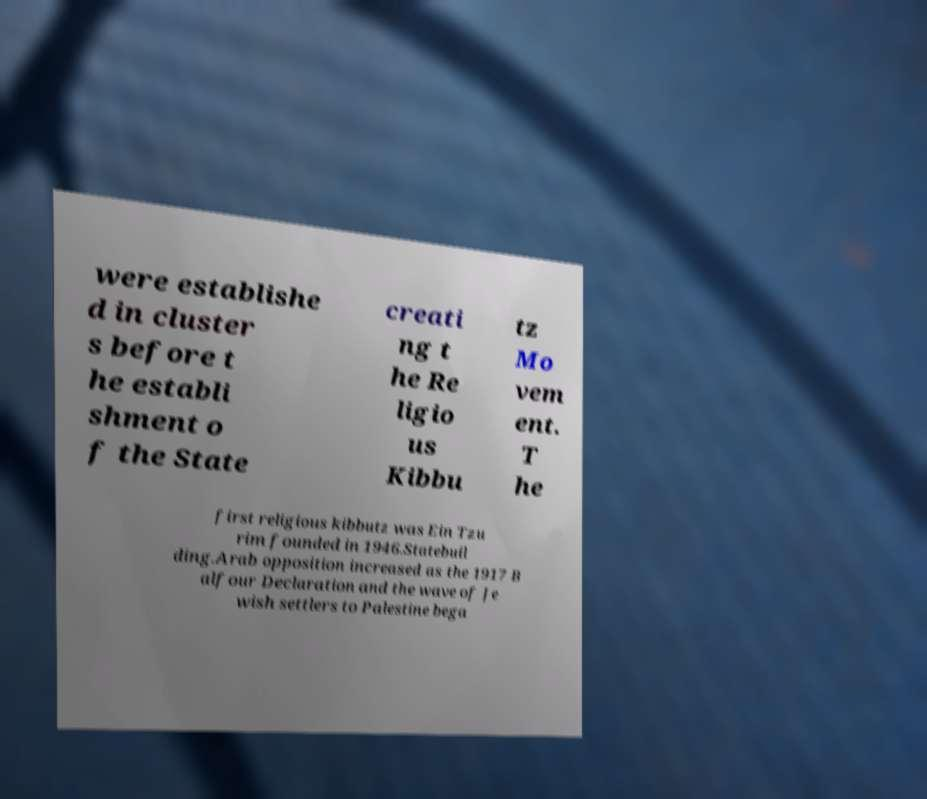For documentation purposes, I need the text within this image transcribed. Could you provide that? were establishe d in cluster s before t he establi shment o f the State creati ng t he Re ligio us Kibbu tz Mo vem ent. T he first religious kibbutz was Ein Tzu rim founded in 1946.Statebuil ding.Arab opposition increased as the 1917 B alfour Declaration and the wave of Je wish settlers to Palestine bega 